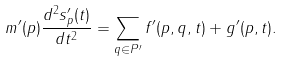Convert formula to latex. <formula><loc_0><loc_0><loc_500><loc_500>m ^ { \prime } ( p ) \frac { d ^ { 2 } s ^ { \prime } _ { p } ( t ) } { d t ^ { 2 } } = \sum _ { q \in P ^ { \prime } } f ^ { \prime } ( p , q , t ) + g ^ { \prime } ( p , t ) .</formula> 